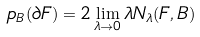<formula> <loc_0><loc_0><loc_500><loc_500>p _ { B } ( \partial F ) = 2 \lim _ { \lambda \to 0 } \lambda N _ { \lambda } ( F , B )</formula> 